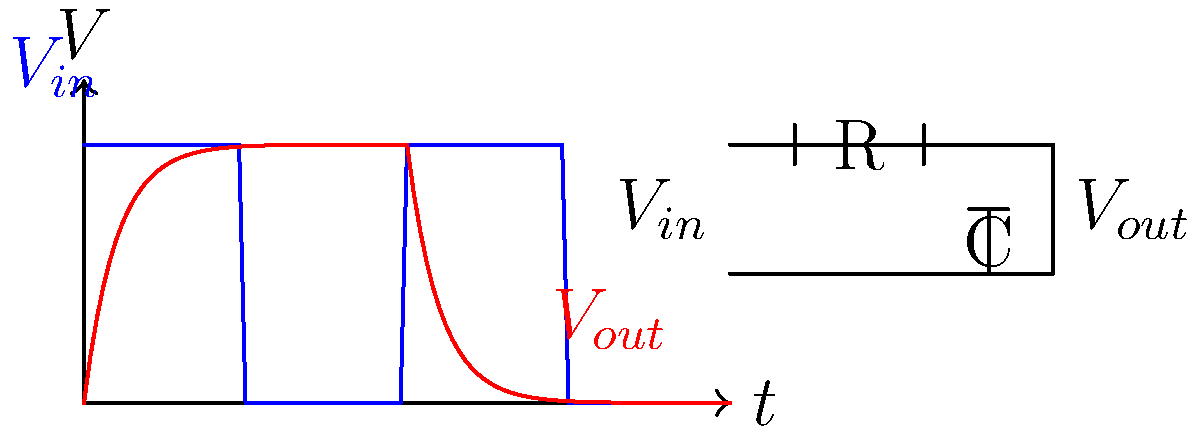In the RC low-pass filter circuit shown above, what is the time constant $\tau$ of the circuit if $R = 10\,\text{k}\Omega$ and $C = 50\,\text{nF}$? How does this time constant relate to the filter's cutoff frequency? To solve this problem, let's follow these steps:

1. Recall the formula for the time constant of an RC circuit:
   $\tau = RC$

2. Given values:
   $R = 10\,\text{k}\Omega = 10,000\,\Omega$
   $C = 50\,\text{nF} = 50 \times 10^{-9}\,\text{F}$

3. Calculate the time constant:
   $\tau = RC = 10,000 \times 50 \times 10^{-9} = 500 \times 10^{-6}\,\text{s} = 500\,\mu\text{s}$

4. The relationship between time constant and cutoff frequency:
   The cutoff frequency $f_c$ is related to the time constant by:
   $f_c = \frac{1}{2\pi\tau}$

5. Calculate the cutoff frequency:
   $f_c = \frac{1}{2\pi(500 \times 10^{-6})} \approx 318.3\,\text{Hz}$

The time constant determines how quickly the circuit responds to changes in input. A larger time constant results in a slower response and a lower cutoff frequency, which means the circuit will filter out higher frequencies more effectively.
Answer: $\tau = 500\,\mu\text{s}$; $f_c = \frac{1}{2\pi\tau} \approx 318.3\,\text{Hz}$ 